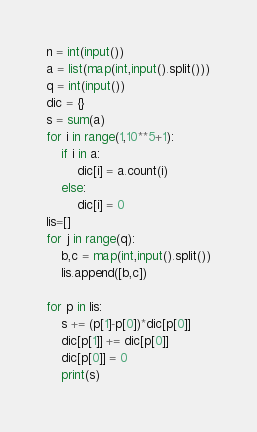<code> <loc_0><loc_0><loc_500><loc_500><_Python_>n = int(input())
a = list(map(int,input().split()))
q = int(input())
dic = {}
s = sum(a)
for i in range(1,10**5+1):
    if i in a:
        dic[i] = a.count(i)
    else:
        dic[i] = 0
lis=[]
for j in range(q):
    b,c = map(int,input().split())
    lis.append([b,c])

for p in lis:
    s += (p[1]-p[0])*dic[p[0]]
    dic[p[1]] += dic[p[0]]
    dic[p[0]] = 0
    print(s)</code> 